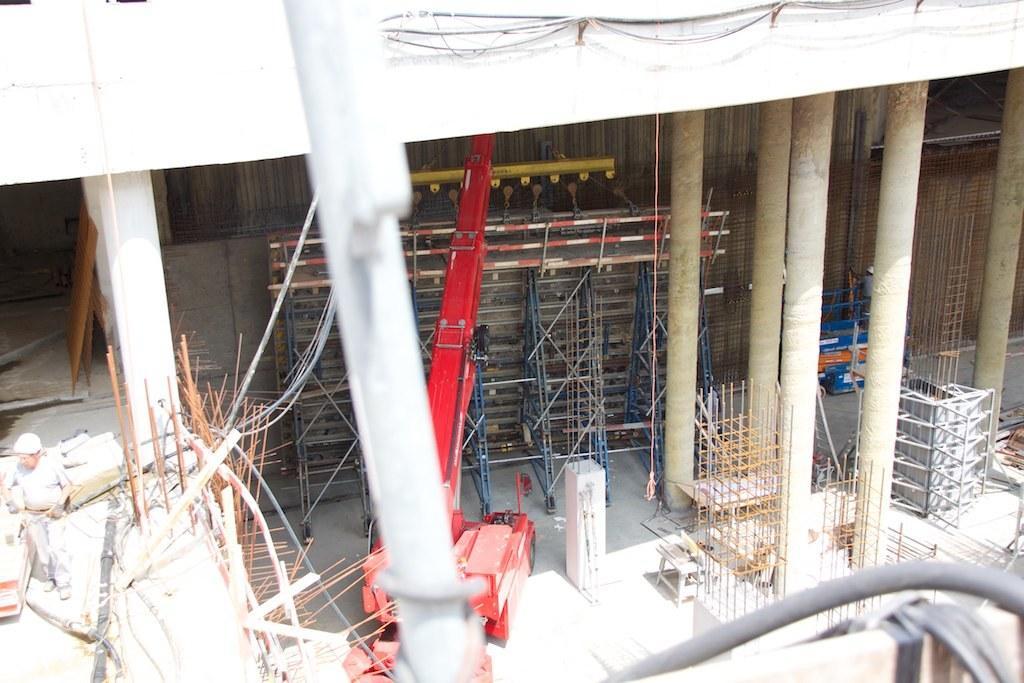In one or two sentences, can you explain what this image depicts? In this image we can see construction of building. There are rods and pillars. Also we can see a crane. On the left side there is a person wearing helmet. 